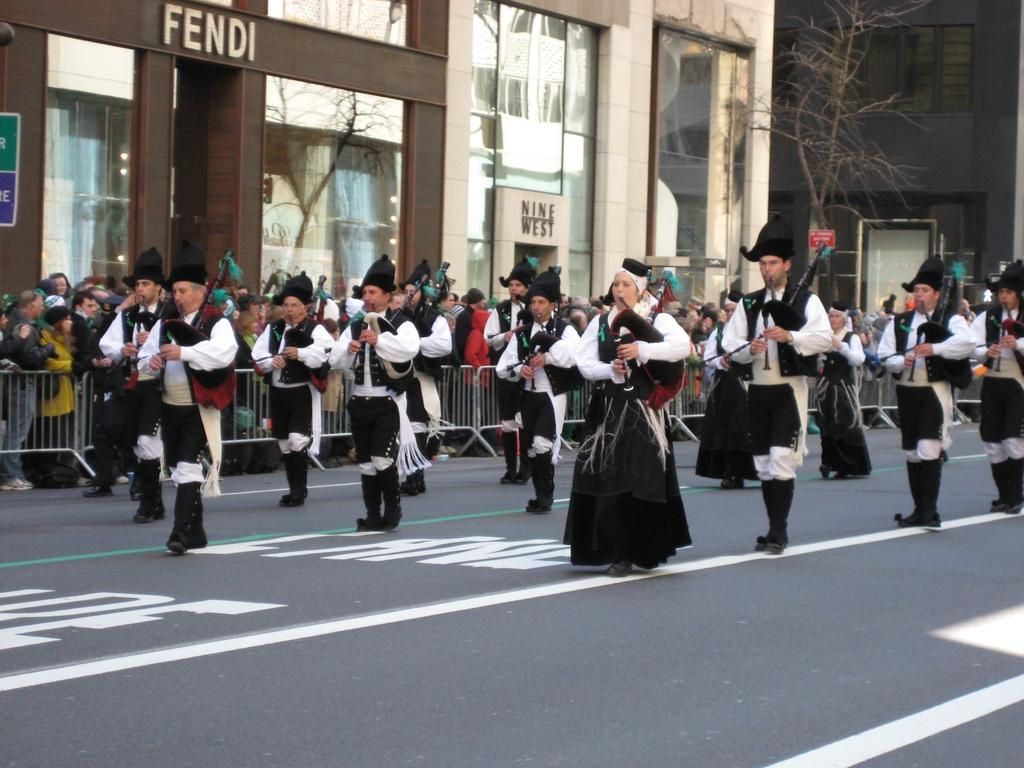How many people are in the image? There is a group of people in the image, but the exact number cannot be determined from the provided facts. What are some people doing in the image? Some people are on the road, and some are holding musical instruments. What can be seen in the background of the image? In the background of the image, there are barricades, buildings, walls, glasses, a tree, and name boards. How many eggs are visible on the pin in the image? There is no pin or eggs present in the image. 